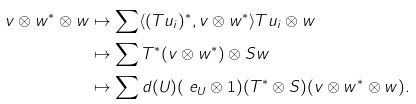<formula> <loc_0><loc_0><loc_500><loc_500>v \otimes w ^ { * } \otimes w & \mapsto \sum \langle ( T u _ { i } ) ^ { * } , v \otimes w ^ { * } \rangle T u _ { i } \otimes w \\ & \mapsto \sum T ^ { * } ( v \otimes w ^ { * } ) \otimes S w \\ & \mapsto \sum d ( U ) ( \ e _ { U } \otimes 1 ) ( T ^ { * } \otimes S ) ( v \otimes w ^ { * } \otimes w ) .</formula> 